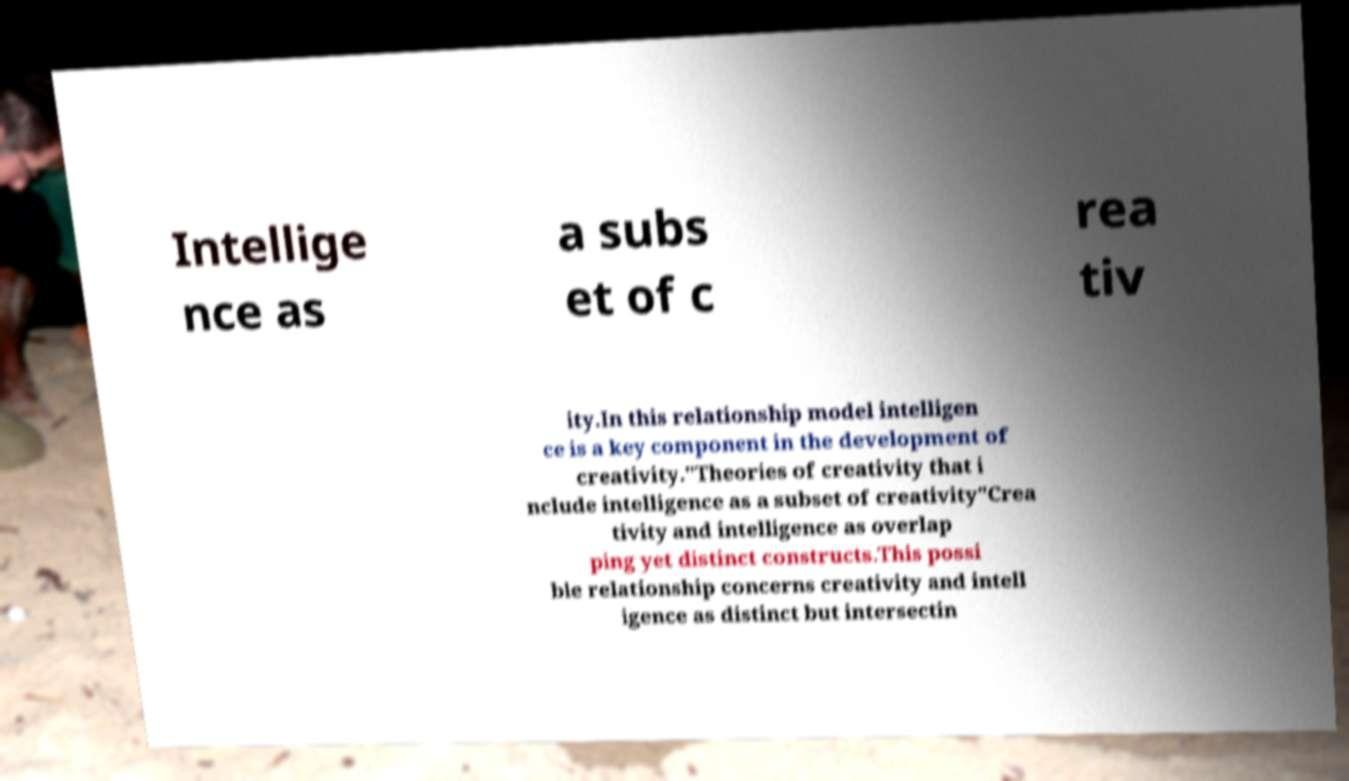Could you extract and type out the text from this image? Intellige nce as a subs et of c rea tiv ity.In this relationship model intelligen ce is a key component in the development of creativity."Theories of creativity that i nclude intelligence as a subset of creativity"Crea tivity and intelligence as overlap ping yet distinct constructs.This possi ble relationship concerns creativity and intell igence as distinct but intersectin 